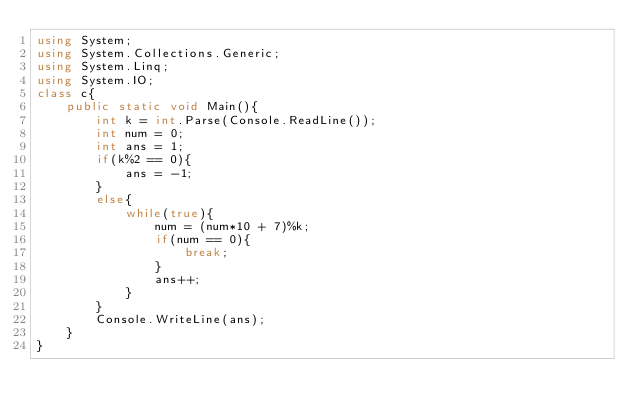Convert code to text. <code><loc_0><loc_0><loc_500><loc_500><_C#_>using System;
using System.Collections.Generic;
using System.Linq;
using System.IO;
class c{
    public static void Main(){
        int k = int.Parse(Console.ReadLine());
        int num = 0;
        int ans = 1;
        if(k%2 == 0){
            ans = -1;
        }
        else{
            while(true){
                num = (num*10 + 7)%k;
                if(num == 0){
                    break;
                }
                ans++;
            }
        }
        Console.WriteLine(ans);
    }
}
</code> 